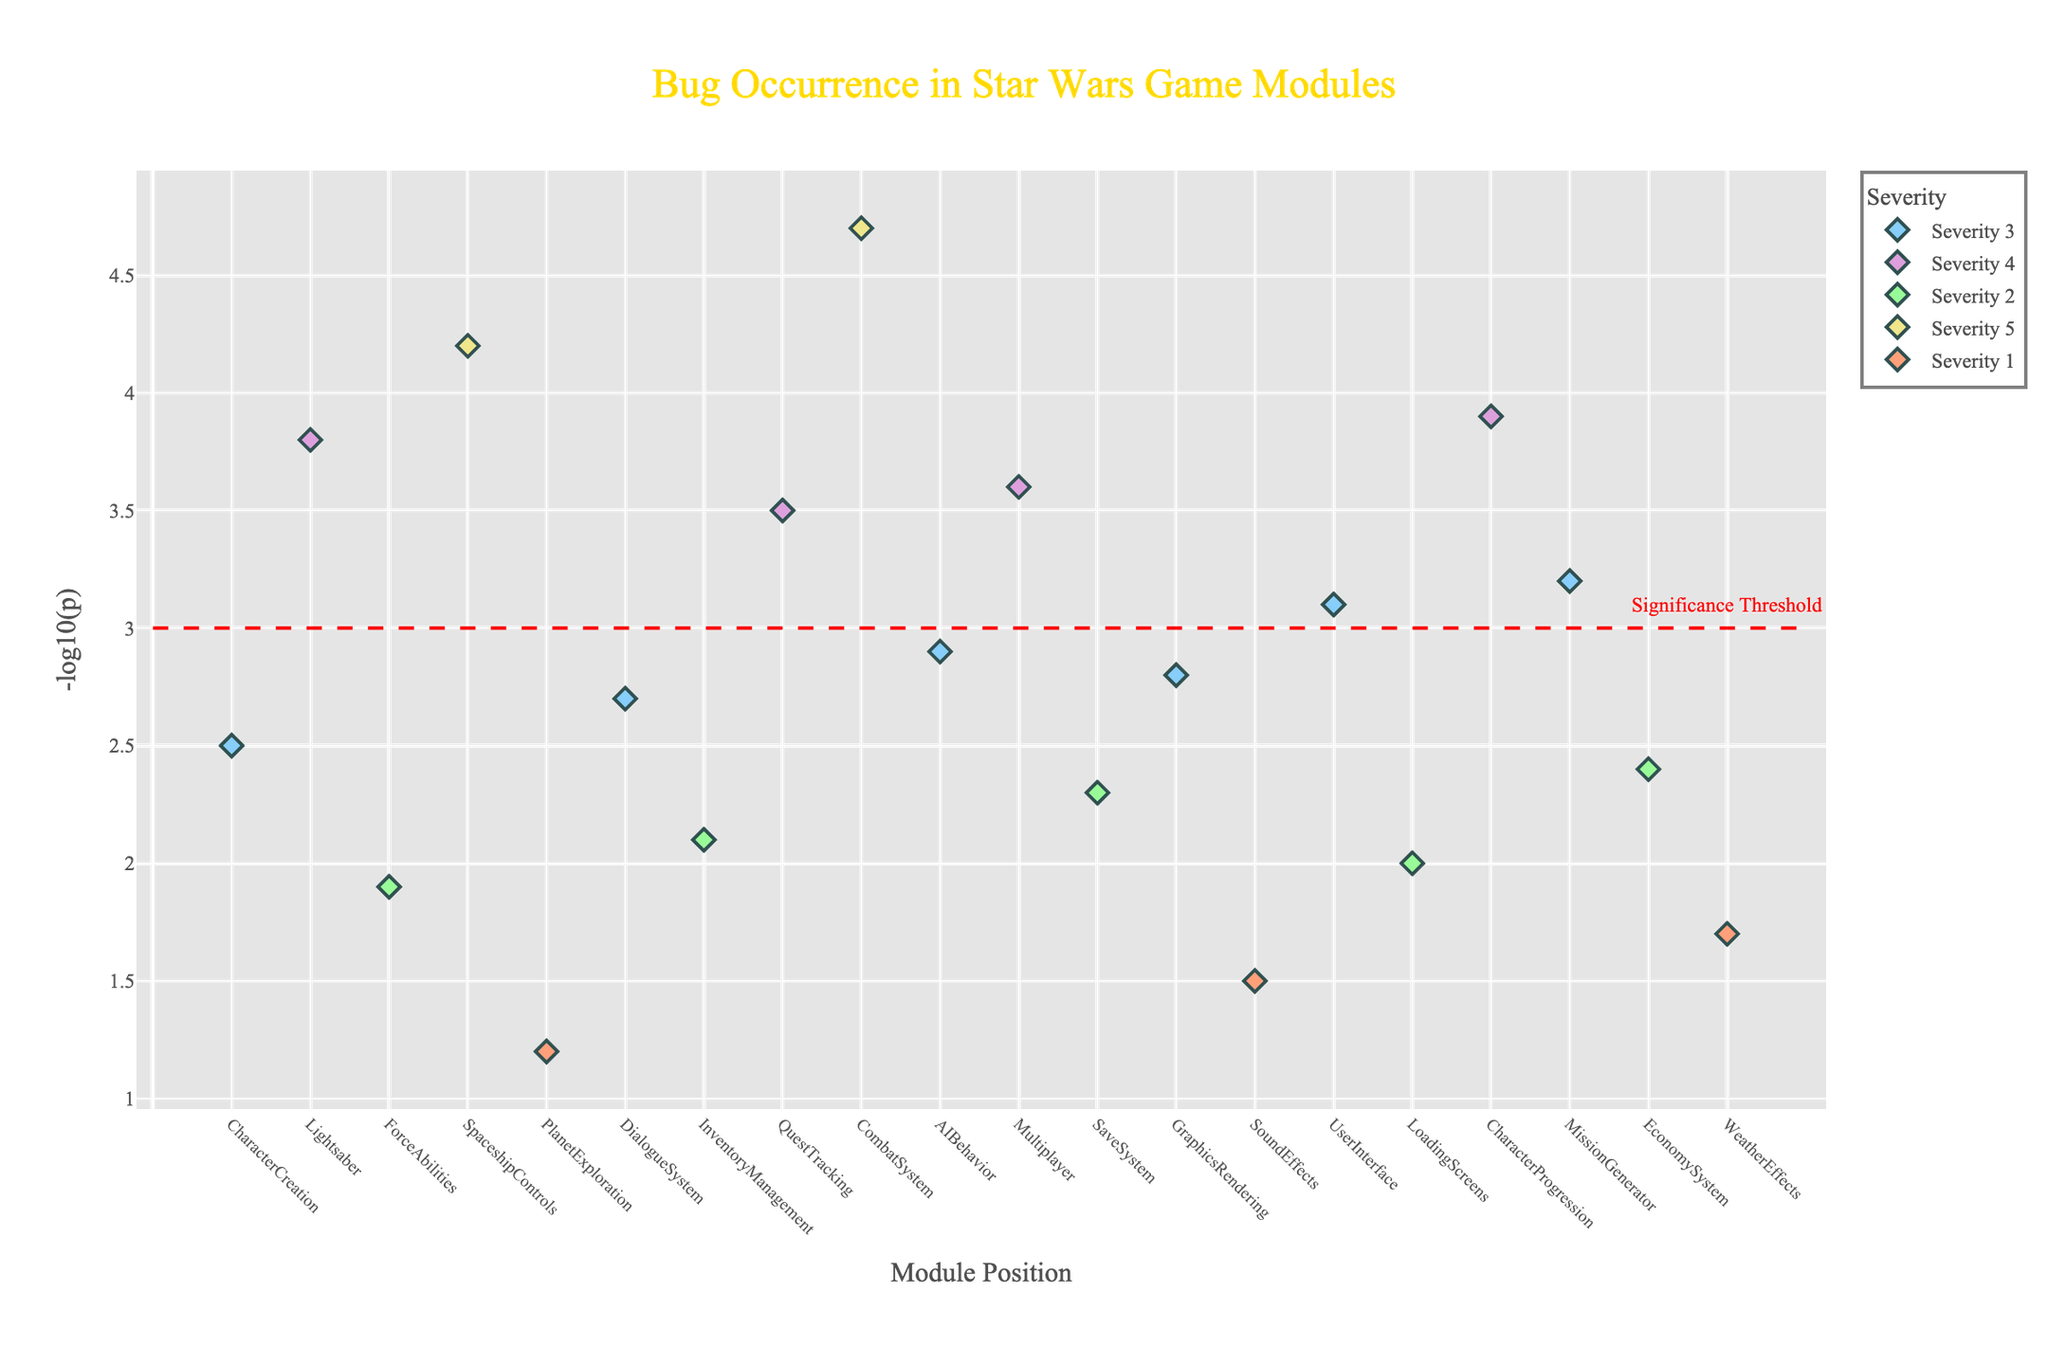Which module has the highest severity level? There are dots for each module, sorted by their severity level. The module with the highest severity level (5) is CombatSystem.
Answer: CombatSystem What is the title of the figure? The title of the figure is written at the top center of the plot.
Answer: Bug Occurrence in Star Wars Game Modules How many modules have a severity level of 4? By counting the different colored dots for severity level 4, we can identify how many there are. There are four modules: Lightsaber, QuestTracking, Multiplayer, and CharacterProgression.
Answer: 4 Which module has the highest -log10(p) value? The plot visually shows the highest point on the y-axis corresponding to the -log10(p) value. The module is CombatSystem with a -log10(p) value of 4.7.
Answer: CombatSystem Which modules have -log10(p) values above the significance threshold? There is a red dashed line representing the significance threshold at y=3. Modules above this line are Lightsaber, SpaceshipControls, QuestTracking, CombatSystem, Multiplayer, CharacterProgression, and MissionGenerator.
Answer: Lightsaber, SpaceshipControls, QuestTracking, CombatSystem, Multiplayer, CharacterProgression, MissionGenerator What are the x-axis and y-axis labels? The x-axis label is "Module Position", and the y-axis label is "-log10(p)", as written near the respective axes.
Answer: Module Position, -log10(p) Which module has the lowest -log10(p) value and what is the value? The lowest point on the y-axis corresponds to PlanetExploration, with the lowest -log10(p) value of 1.2.
Answer: PlanetExploration, 1.2 Compare the -log10(p) values of Lightsaber and LoadingScreens. Which one is higher? By identifying the positions of Lightsaber and LoadingScreens on the plot and comparing their heights, we see that Lightsaber has a value of 3.8, whereas LoadingScreens has a value of 2. LoadingScreens's value is lower.
Answer: Lightsaber Which severity level has the most modules above the significance threshold? Counting the number of dots above the red dashed line and associating them with their respective severity levels. Severity level 4 has the most modules above the threshold (Lightsaber, QuestTracking, Multiplayer, CharacterProgression).
Answer: Severity level 4 What is the range of -log10(p) values for severity level 3? Locating all the points for severity level 3 and identifying their y-axis values, which range from 2.5 to 3.2.
Answer: 2.5 to 3.2 